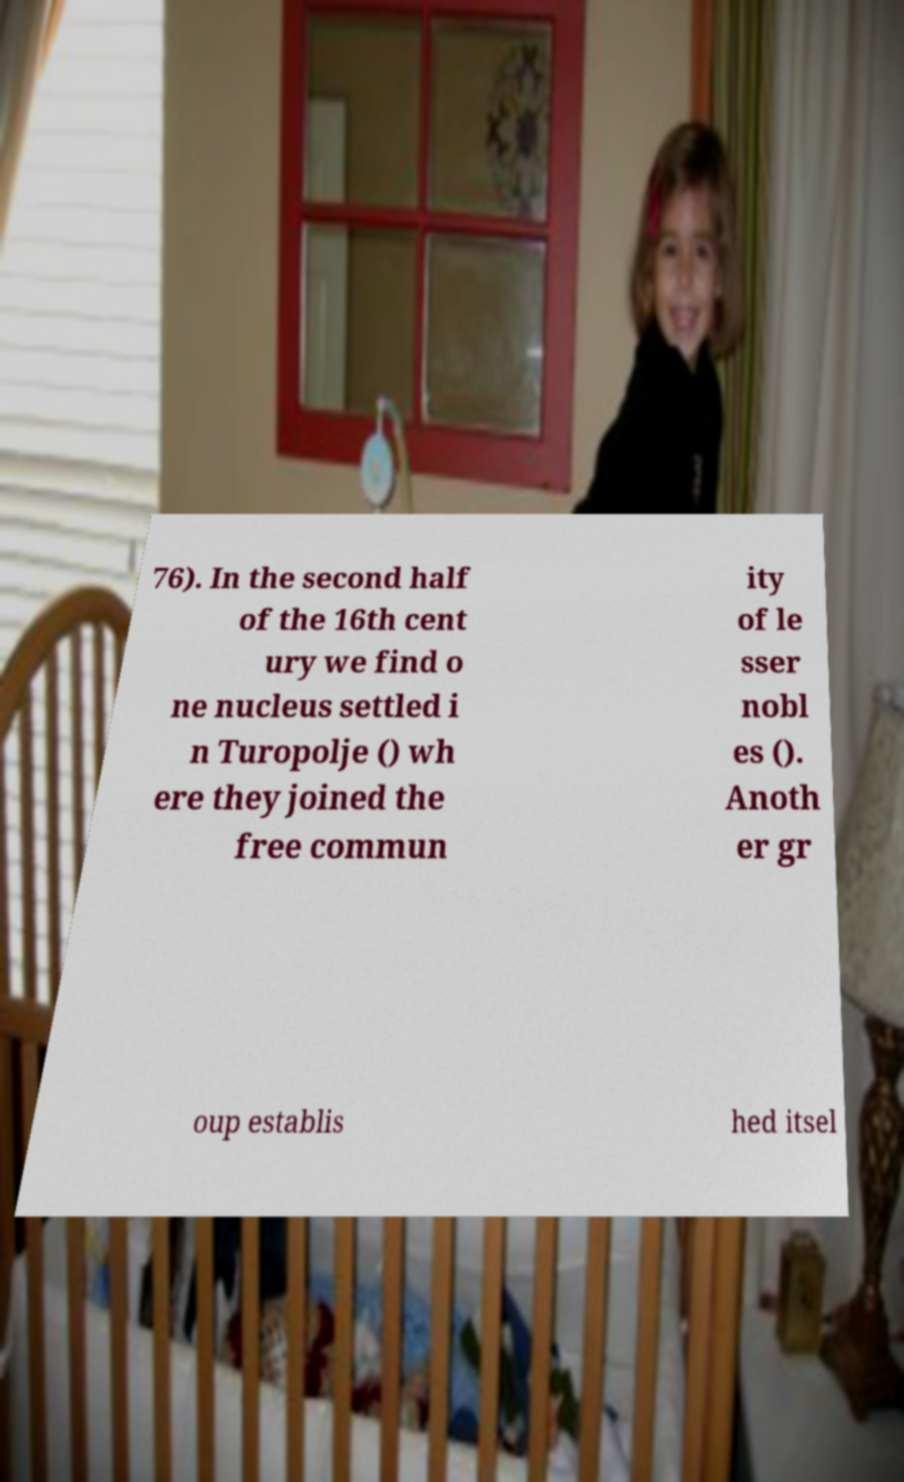There's text embedded in this image that I need extracted. Can you transcribe it verbatim? 76). In the second half of the 16th cent ury we find o ne nucleus settled i n Turopolje () wh ere they joined the free commun ity of le sser nobl es (). Anoth er gr oup establis hed itsel 